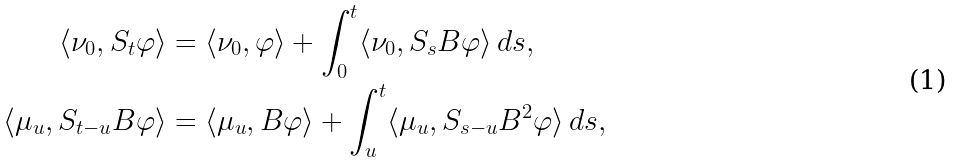Convert formula to latex. <formula><loc_0><loc_0><loc_500><loc_500>\langle \nu _ { 0 } , S _ { t } \varphi \rangle & = \langle \nu _ { 0 } , \varphi \rangle + \int _ { 0 } ^ { t } \langle \nu _ { 0 } , S _ { s } B \varphi \rangle \, d s , \\ \langle \mu _ { u } , S _ { t - u } B \varphi \rangle & = \langle \mu _ { u } , B \varphi \rangle + \int _ { u } ^ { t } \langle \mu _ { u } , S _ { s - u } B ^ { 2 } \varphi \rangle \, d s ,</formula> 